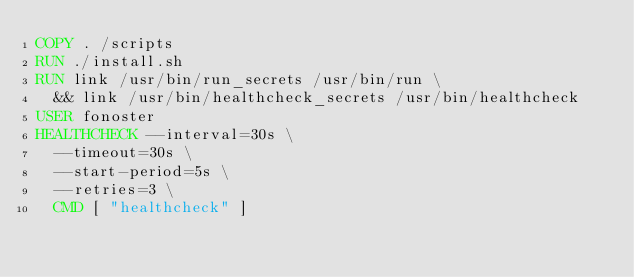<code> <loc_0><loc_0><loc_500><loc_500><_Dockerfile_>COPY . /scripts
RUN ./install.sh
RUN link /usr/bin/run_secrets /usr/bin/run \
  && link /usr/bin/healthcheck_secrets /usr/bin/healthcheck
USER fonoster
HEALTHCHECK --interval=30s \
  --timeout=30s \
  --start-period=5s \
  --retries=3 \
  CMD [ "healthcheck" ]
</code> 